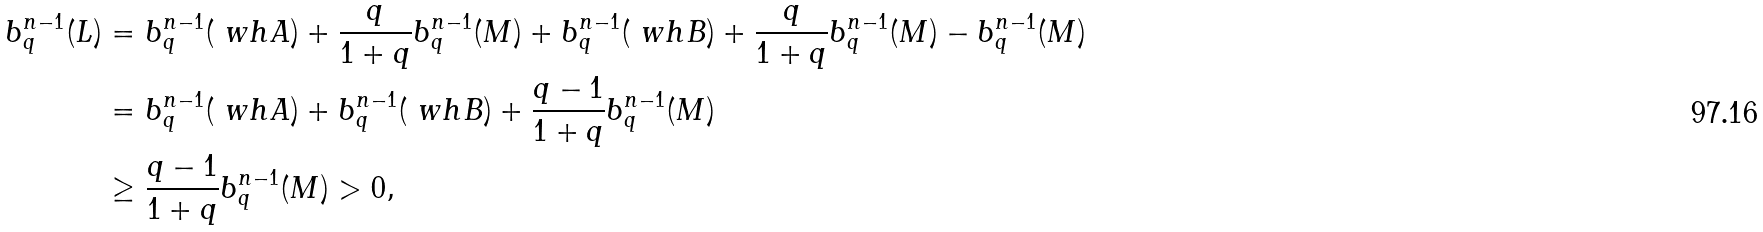<formula> <loc_0><loc_0><loc_500><loc_500>b ^ { n - 1 } _ { q } ( L ) & = b ^ { n - 1 } _ { q } ( \ w h { A } ) + \frac { q } { 1 + q } b ^ { n - 1 } _ { q } ( M ) + b ^ { n - 1 } _ { q } ( \ w h { B } ) + \frac { q } { 1 + q } b ^ { n - 1 } _ { q } ( M ) - b ^ { n - 1 } _ { q } ( M ) \\ & = b ^ { n - 1 } _ { q } ( \ w h { A } ) + b ^ { n - 1 } _ { q } ( \ w h { B } ) + \frac { q - 1 } { 1 + q } b ^ { n - 1 } _ { q } ( M ) \\ & \geq \frac { q - 1 } { 1 + q } b ^ { n - 1 } _ { q } ( M ) > 0 ,</formula> 